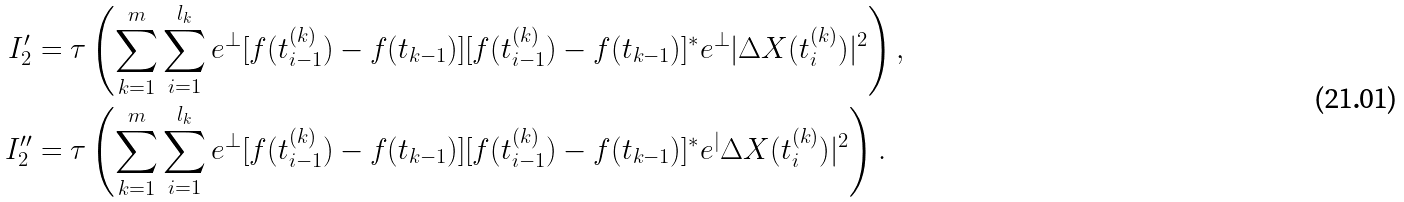Convert formula to latex. <formula><loc_0><loc_0><loc_500><loc_500>I _ { 2 } ^ { \prime } & = \tau \left ( \sum _ { k = 1 } ^ { m } \sum _ { i = 1 } ^ { l _ { k } } e ^ { \bot } [ f ( t _ { i - 1 } ^ { ( k ) } ) - f ( t _ { k - 1 } ) ] [ f ( t _ { i - 1 } ^ { ( k ) } ) - f ( t _ { k - 1 } ) ] ^ { * } e ^ { \bot } | \Delta X ( t _ { i } ^ { ( k ) } ) | ^ { 2 } \right ) , \\ I _ { 2 } ^ { \prime \prime } & = \tau \left ( \sum _ { k = 1 } ^ { m } \sum _ { i = 1 } ^ { l _ { k } } e ^ { \bot } [ f ( t _ { i - 1 } ^ { ( k ) } ) - f ( t _ { k - 1 } ) ] [ f ( t _ { i - 1 } ^ { ( k ) } ) - f ( t _ { k - 1 } ) ] ^ { * } e ^ { | } \Delta X ( t _ { i } ^ { ( k ) } ) | ^ { 2 } \right ) .</formula> 